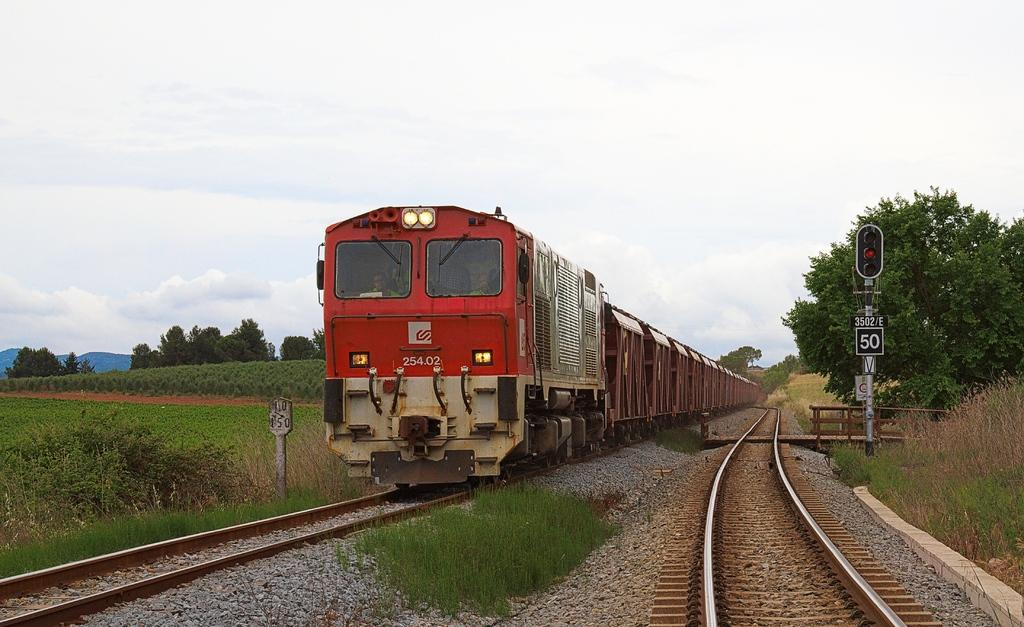<image>
Summarize the visual content of the image. A red train that has the number 25402 on the front is going past a traffic signal. 